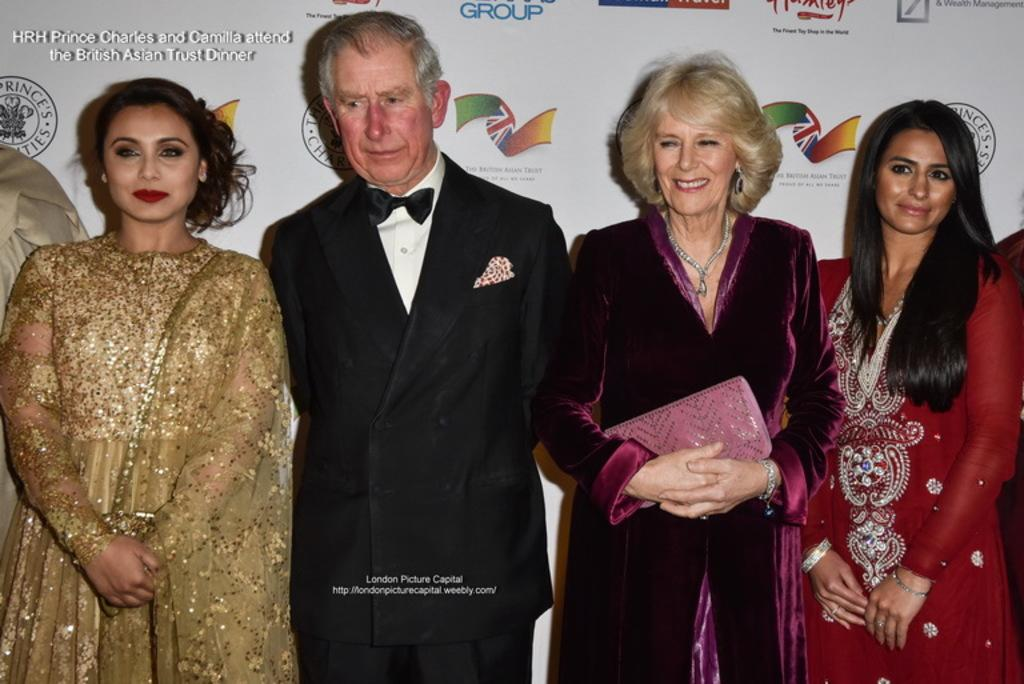What is happening with the people in the image? The people in the image are standing and smiling. Can you describe the actions of one of the people? One person is holding an object in the image. What can be seen in the background of the image? There is a poster with images and text in the background. What type of force is being applied by the cats in the image? There are no cats present in the image, so no force can be applied by them. What kind of apparatus is being used by the people in the image? The facts provided do not mention any specific apparatus being used by the people in the image. 